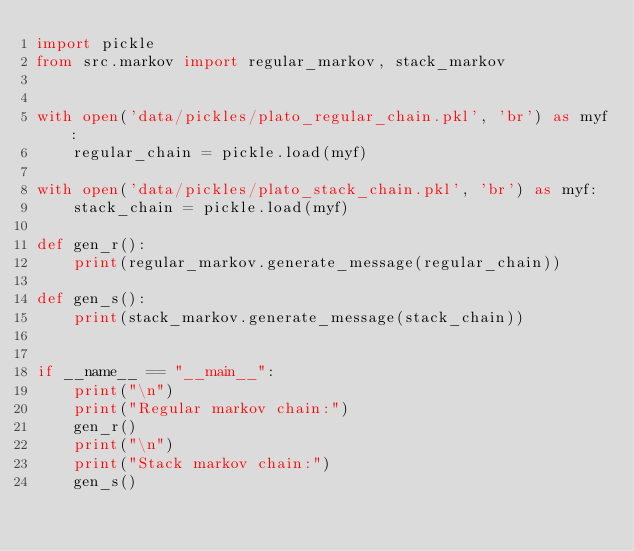<code> <loc_0><loc_0><loc_500><loc_500><_Python_>import pickle
from src.markov import regular_markov, stack_markov


with open('data/pickles/plato_regular_chain.pkl', 'br') as myf:
    regular_chain = pickle.load(myf)

with open('data/pickles/plato_stack_chain.pkl', 'br') as myf:
    stack_chain = pickle.load(myf)

def gen_r():
    print(regular_markov.generate_message(regular_chain))

def gen_s():
    print(stack_markov.generate_message(stack_chain))


if __name__ == "__main__":
    print("\n")
    print("Regular markov chain:")
    gen_r()
    print("\n")
    print("Stack markov chain:")
    gen_s()
</code> 